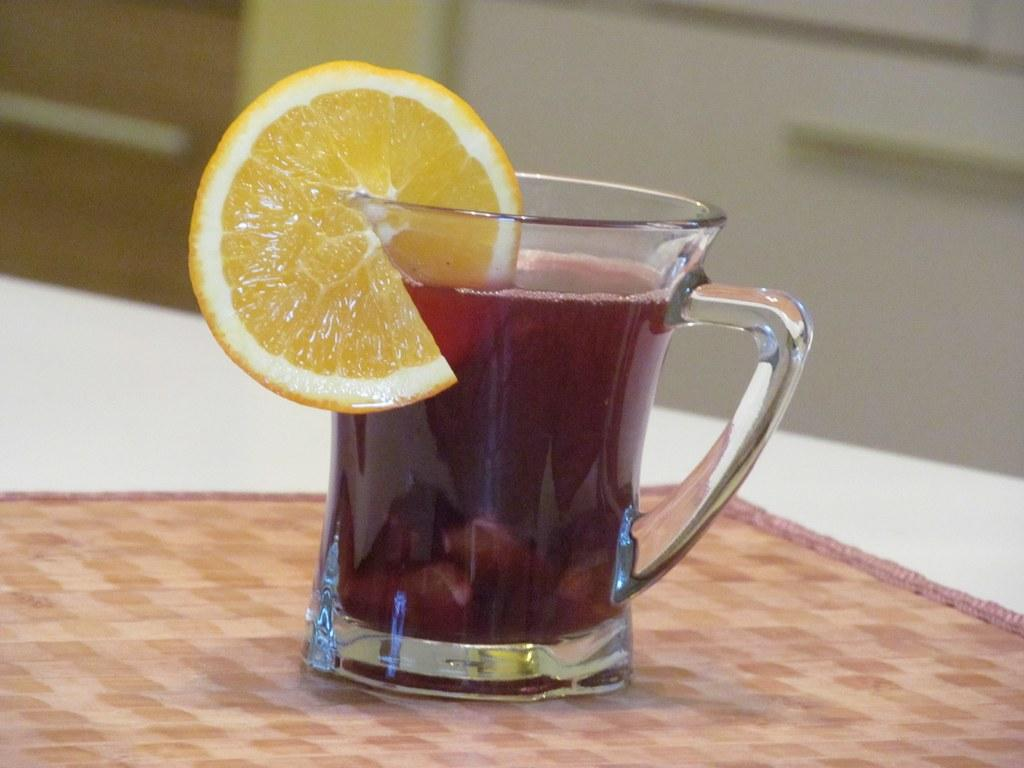What is in the mug that is visible in the image? There is a mug of juice in the image. What additional item can be seen in the image? There is a slice of lemon in the image. What type of organization is depicted in the image? There is no organization depicted in the image; it only features a mug of juice and a slice of lemon. How many lizards can be seen in the image? There are no lizards present in the image. 